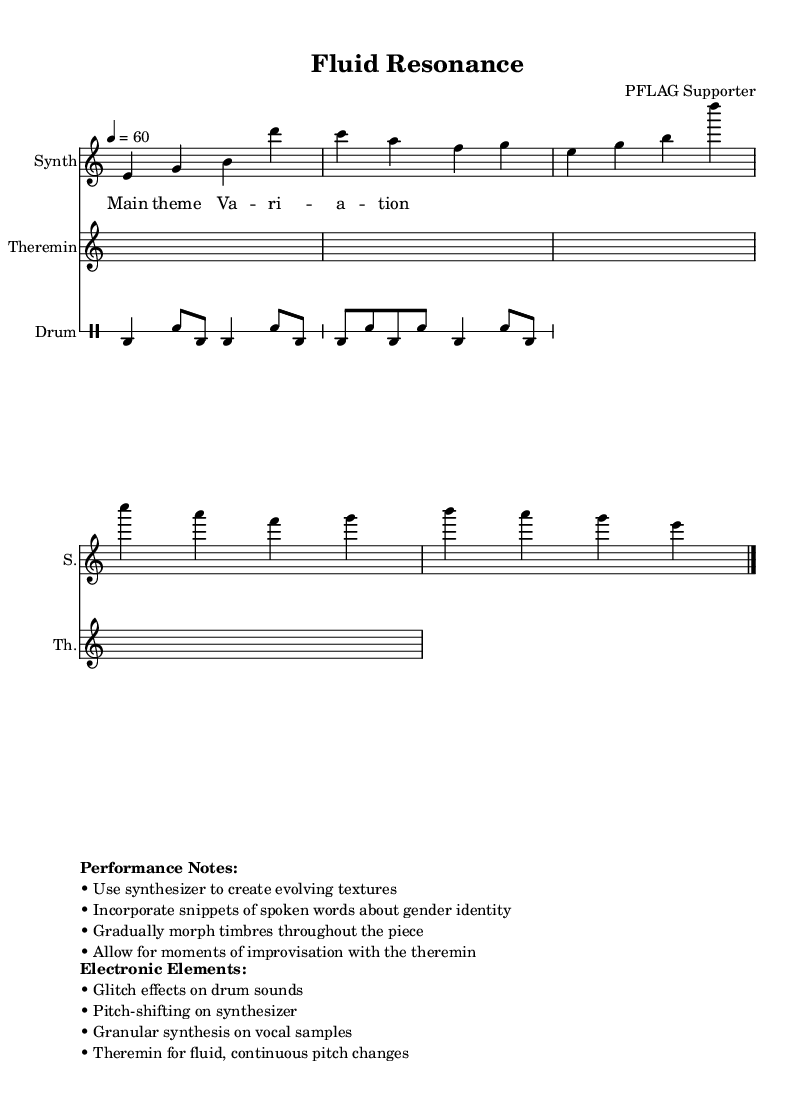What is the title of this piece? The title is indicated at the top of the sheet music under the header section.
Answer: Fluid Resonance What is the time signature of this music? The time signature is located in the global section, represented as a fraction of beats per measure. Here, it specifies 4/4.
Answer: 4/4 What is the tempo marking for the piece? The tempo marking is located in the global section and is defined as a number indicating the beats per minute. It is set at 60.
Answer: 60 How many measures are present in the synthesizer music? By counting the number of bar lines or measures in the synthMusic section, we find there are two distinct measures.
Answer: 2 What instruments are used in this piece? The instruments are listed in the score sections for each staff. They include Synth, Theremin, and Drum.
Answer: Synth, Theremin, Drum What electronic element is suggested for modifying drum sounds? The performance notes specify which effects to apply. Here, it mentions glitch effects specifically for the drum sounds.
Answer: Glitch effects What is a notable feature of the theremin's part? The performance notes indicate that the theremin should allow for moments of improvisation, highlighting its unique, fluid pitch capabilities.
Answer: Improvisation 